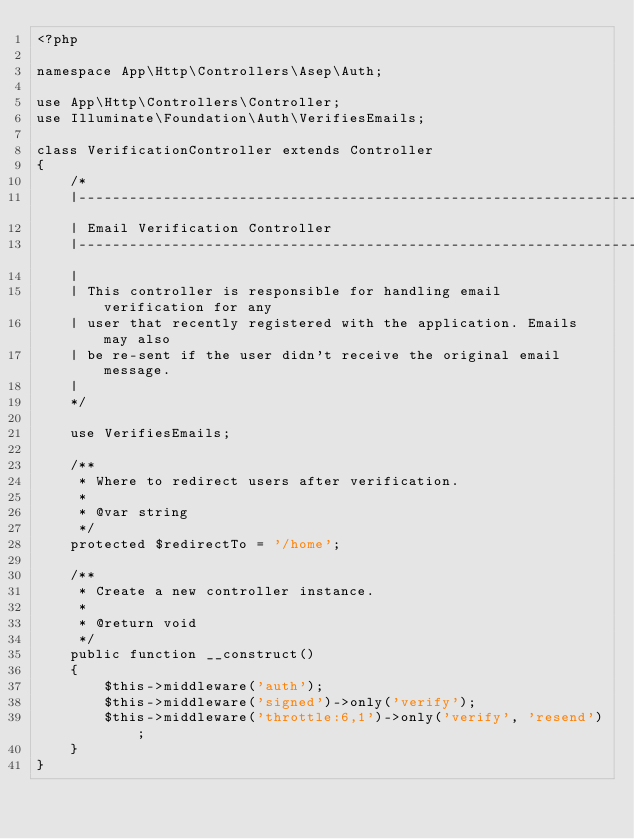<code> <loc_0><loc_0><loc_500><loc_500><_PHP_><?php

namespace App\Http\Controllers\Asep\Auth;

use App\Http\Controllers\Controller;
use Illuminate\Foundation\Auth\VerifiesEmails;

class VerificationController extends Controller
{
    /*
    |--------------------------------------------------------------------------
    | Email Verification Controller
    |--------------------------------------------------------------------------
    |
    | This controller is responsible for handling email verification for any
    | user that recently registered with the application. Emails may also
    | be re-sent if the user didn't receive the original email message.
    |
    */

    use VerifiesEmails;

    /**
     * Where to redirect users after verification.
     *
     * @var string
     */
    protected $redirectTo = '/home';

    /**
     * Create a new controller instance.
     *
     * @return void
     */
    public function __construct()
    {
        $this->middleware('auth');
        $this->middleware('signed')->only('verify');
        $this->middleware('throttle:6,1')->only('verify', 'resend');
    }
}
</code> 